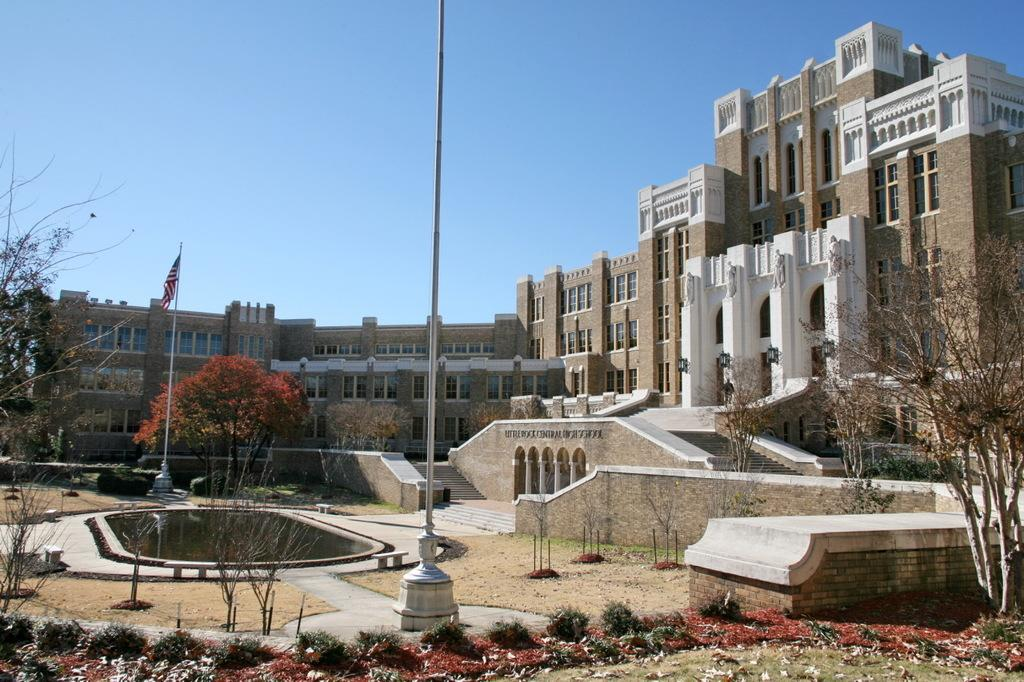What type of structures can be seen in the image? There are buildings in the image. What is located in front of the buildings? There is a staircase in front of the buildings. What natural element is present in the image? There is a pond in the image. What type of vegetation can be seen in the image? There are trees and plants in the image. What is the symbolic object in the image? There is a flag in the image. What are the vertical supports in the image used for? There are poles in the image, which might be used for various purposes such as supporting the flag or providing lighting. Can you describe any other objects in the image? There are a few other objects in the image, but their specific details are not mentioned in the provided facts. How many times do the people in the image kiss each other? There are no people visible in the image, so it is not possible to determine if they are kissing or how many times. What type of line is drawn across the pond in the image? There is no line drawn across the pond in the image. 